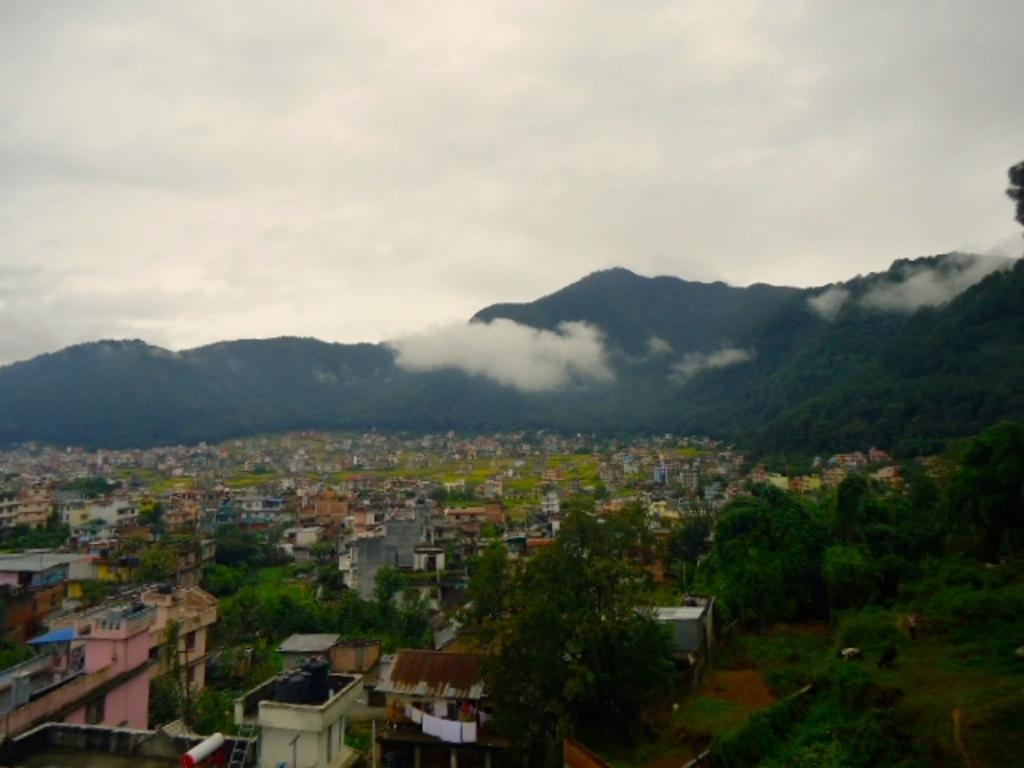What type of structures can be seen in the image? There are houses in the image. What natural feature is present in the image? There is a hill in the image. What atmospheric condition is depicted in the image? There is mist in the image. What type of vegetation is visible in the image? There are surrounding trees visible in the image. What can be seen in the sky in the image? Clouds are present in the sky in the image. Can you hear the goldfish singing a song in the image? There is no goldfish or song present in the image; it features houses, a hill, mist, trees, and clouds. 